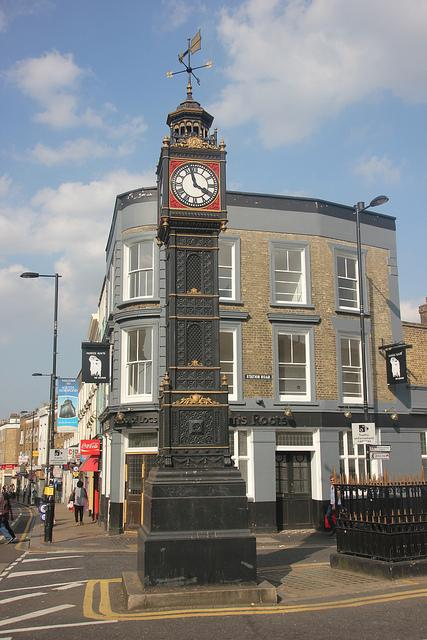This street is located where?

Choices:
A) field
B) suburb
C) city
D) desert city 